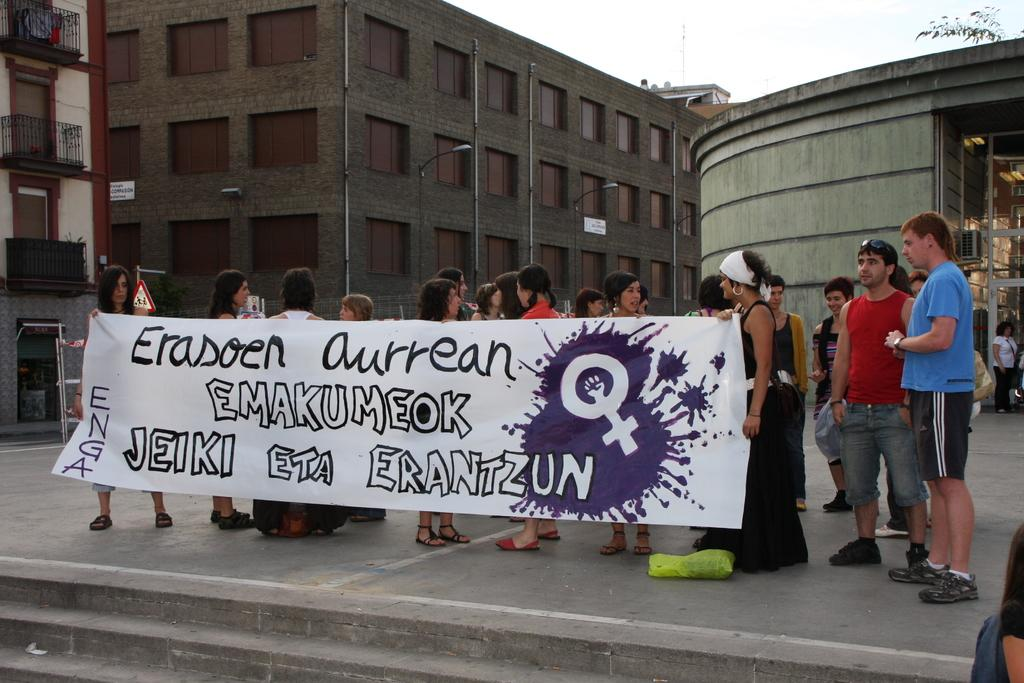What are the people in the image doing? The people in the image are holding a banner. What architectural feature can be seen at the bottom of the image? There are stairs at the bottom of the image. What type of structures can be seen in the image? There are buildings visible in the image. What objects are present in the image that might be used for support or display? There are poles in the image. What type of vegetation is present in the image? There is a tree in the image. What is visible in the background of the image? The sky is visible in the background of the image. What type of metal is the daughter using to sculpt a wax figure in the image? There is no daughter or wax figure present in the image. 